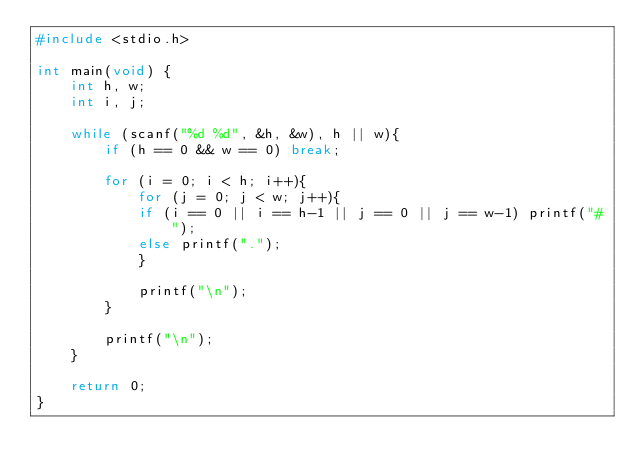<code> <loc_0><loc_0><loc_500><loc_500><_C_>#include <stdio.h>

int main(void) {
	int h, w;
	int i, j;
	
	while (scanf("%d %d", &h, &w), h || w){
		if (h == 0 && w == 0) break;
		
		for (i = 0; i < h; i++){
			for (j = 0; j < w; j++){
			if (i == 0 || i == h-1 || j == 0 || j == w-1) printf("#");
			else printf(".");
			}
			
			printf("\n");
		}
		
		printf("\n");
	}
		
	return 0;
}</code> 